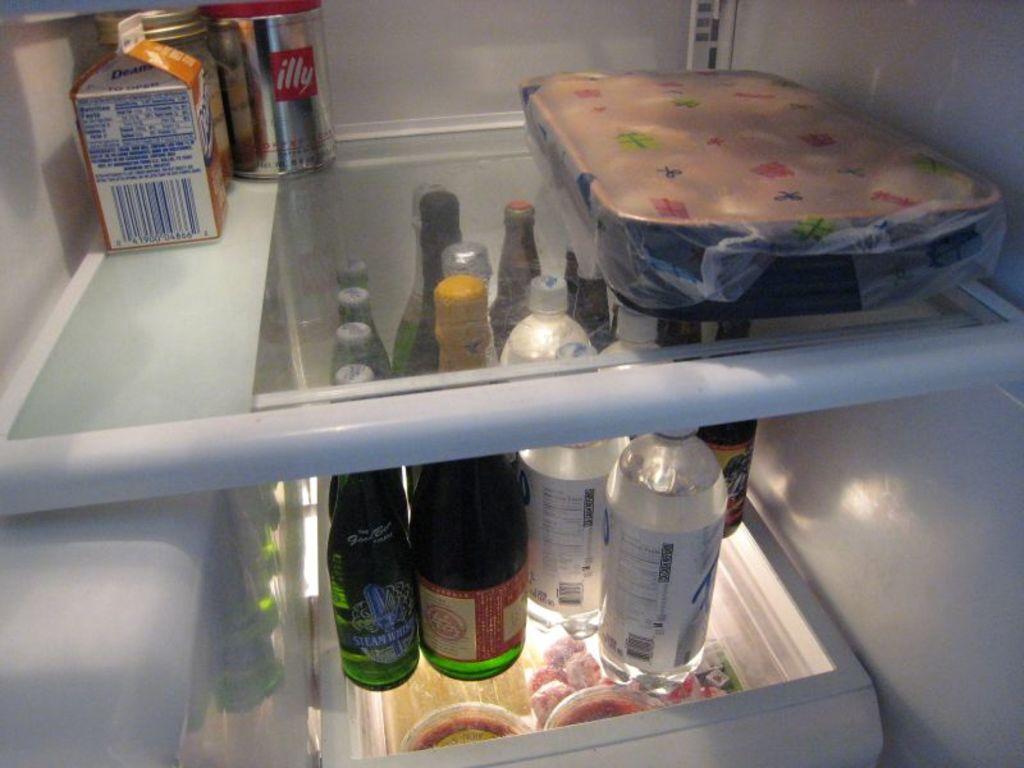What is the name of the product in red on the top shelf?
Offer a very short reply. Illy. 